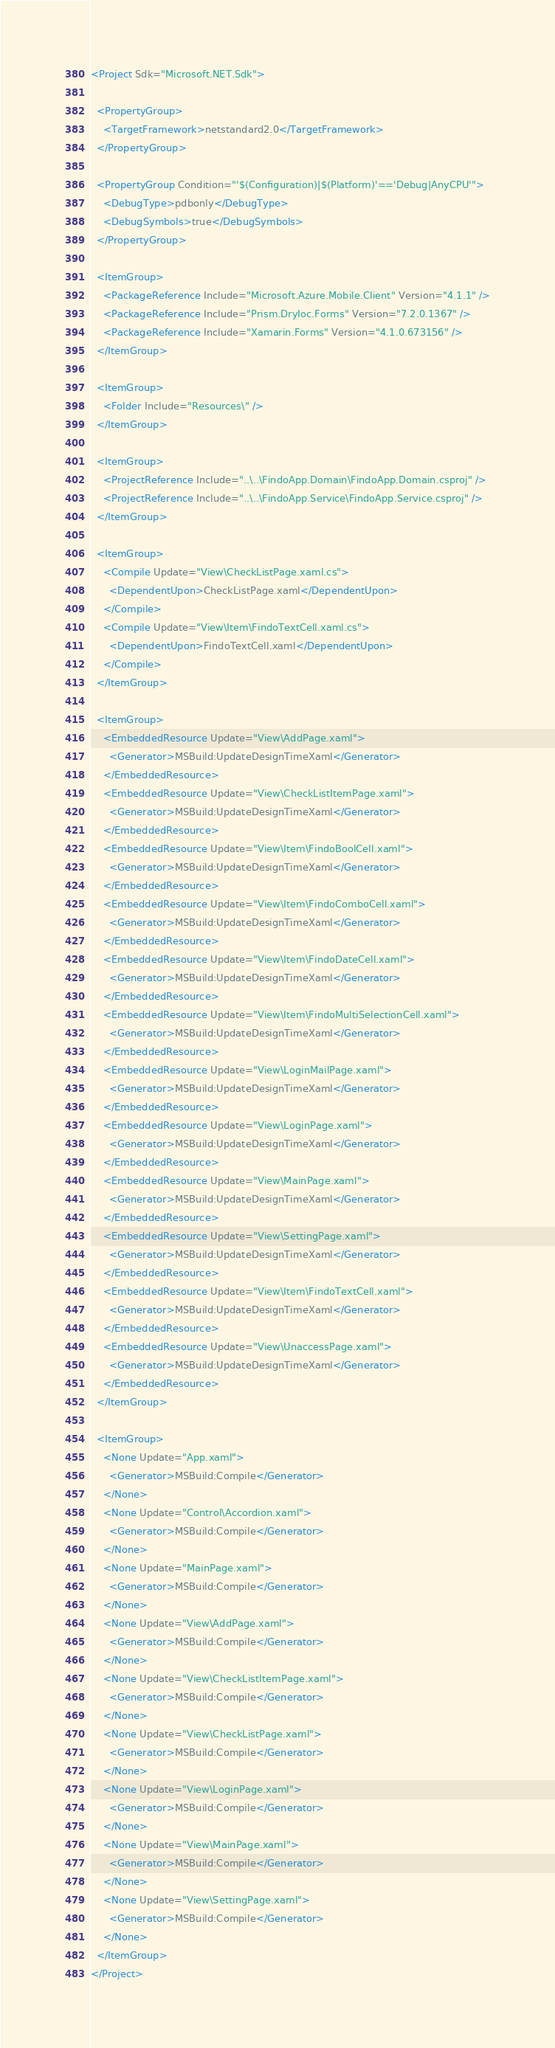<code> <loc_0><loc_0><loc_500><loc_500><_XML_><Project Sdk="Microsoft.NET.Sdk">

  <PropertyGroup>
    <TargetFramework>netstandard2.0</TargetFramework>
  </PropertyGroup>

  <PropertyGroup Condition="'$(Configuration)|$(Platform)'=='Debug|AnyCPU'">
    <DebugType>pdbonly</DebugType>
    <DebugSymbols>true</DebugSymbols>
  </PropertyGroup>

  <ItemGroup>
    <PackageReference Include="Microsoft.Azure.Mobile.Client" Version="4.1.1" />
    <PackageReference Include="Prism.DryIoc.Forms" Version="7.2.0.1367" />
    <PackageReference Include="Xamarin.Forms" Version="4.1.0.673156" />
  </ItemGroup>

  <ItemGroup>
    <Folder Include="Resources\" />
  </ItemGroup>

  <ItemGroup>
    <ProjectReference Include="..\..\FindoApp.Domain\FindoApp.Domain.csproj" />
    <ProjectReference Include="..\..\FindoApp.Service\FindoApp.Service.csproj" />
  </ItemGroup>

  <ItemGroup>
    <Compile Update="View\CheckListPage.xaml.cs">
      <DependentUpon>CheckListPage.xaml</DependentUpon>
    </Compile>
    <Compile Update="View\Item\FindoTextCell.xaml.cs">
      <DependentUpon>FindoTextCell.xaml</DependentUpon>
    </Compile>
  </ItemGroup>

  <ItemGroup>
    <EmbeddedResource Update="View\AddPage.xaml">
      <Generator>MSBuild:UpdateDesignTimeXaml</Generator>
    </EmbeddedResource>
    <EmbeddedResource Update="View\CheckListItemPage.xaml">
      <Generator>MSBuild:UpdateDesignTimeXaml</Generator>
    </EmbeddedResource>
    <EmbeddedResource Update="View\Item\FindoBoolCell.xaml">
      <Generator>MSBuild:UpdateDesignTimeXaml</Generator>
    </EmbeddedResource>
    <EmbeddedResource Update="View\Item\FindoComboCell.xaml">
      <Generator>MSBuild:UpdateDesignTimeXaml</Generator>
    </EmbeddedResource>
    <EmbeddedResource Update="View\Item\FindoDateCell.xaml">
      <Generator>MSBuild:UpdateDesignTimeXaml</Generator>
    </EmbeddedResource>
    <EmbeddedResource Update="View\Item\FindoMultiSelectionCell.xaml">
      <Generator>MSBuild:UpdateDesignTimeXaml</Generator>
    </EmbeddedResource>
    <EmbeddedResource Update="View\LoginMailPage.xaml">
      <Generator>MSBuild:UpdateDesignTimeXaml</Generator>
    </EmbeddedResource>
    <EmbeddedResource Update="View\LoginPage.xaml">
      <Generator>MSBuild:UpdateDesignTimeXaml</Generator>
    </EmbeddedResource>
    <EmbeddedResource Update="View\MainPage.xaml">
      <Generator>MSBuild:UpdateDesignTimeXaml</Generator>
    </EmbeddedResource>
    <EmbeddedResource Update="View\SettingPage.xaml">
      <Generator>MSBuild:UpdateDesignTimeXaml</Generator>
    </EmbeddedResource>
    <EmbeddedResource Update="View\Item\FindoTextCell.xaml">
      <Generator>MSBuild:UpdateDesignTimeXaml</Generator>
    </EmbeddedResource>
    <EmbeddedResource Update="View\UnaccessPage.xaml">
      <Generator>MSBuild:UpdateDesignTimeXaml</Generator>
    </EmbeddedResource>
  </ItemGroup>

  <ItemGroup>
    <None Update="App.xaml">
      <Generator>MSBuild:Compile</Generator>
    </None>
    <None Update="Control\Accordion.xaml">
      <Generator>MSBuild:Compile</Generator>
    </None>
    <None Update="MainPage.xaml">
      <Generator>MSBuild:Compile</Generator>
    </None>
    <None Update="View\AddPage.xaml">
      <Generator>MSBuild:Compile</Generator>
    </None>
    <None Update="View\CheckListItemPage.xaml">
      <Generator>MSBuild:Compile</Generator>
    </None>
    <None Update="View\CheckListPage.xaml">
      <Generator>MSBuild:Compile</Generator>
    </None>
    <None Update="View\LoginPage.xaml">
      <Generator>MSBuild:Compile</Generator>
    </None>
    <None Update="View\MainPage.xaml">
      <Generator>MSBuild:Compile</Generator>
    </None>
    <None Update="View\SettingPage.xaml">
      <Generator>MSBuild:Compile</Generator>
    </None>
  </ItemGroup>
</Project></code> 